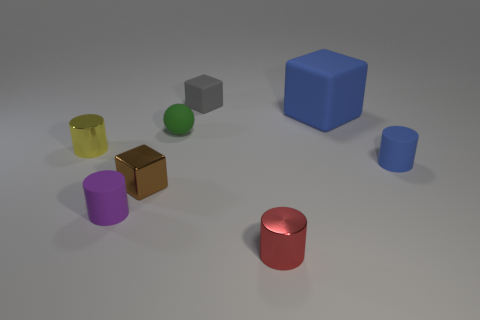Subtract 1 cylinders. How many cylinders are left? 3 Subtract all red cylinders. How many cylinders are left? 3 Subtract all small cubes. How many cubes are left? 1 Subtract all brown cylinders. Subtract all red cubes. How many cylinders are left? 4 Add 1 tiny green objects. How many objects exist? 9 Subtract all spheres. How many objects are left? 7 Subtract all small things. Subtract all large rubber cubes. How many objects are left? 0 Add 2 small blue matte cylinders. How many small blue matte cylinders are left? 3 Add 8 purple cubes. How many purple cubes exist? 8 Subtract 0 red balls. How many objects are left? 8 